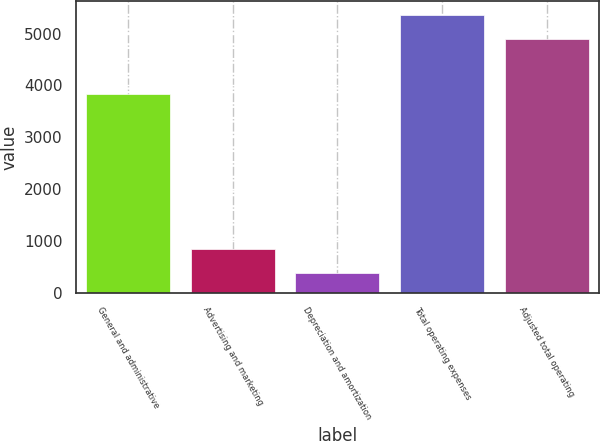Convert chart. <chart><loc_0><loc_0><loc_500><loc_500><bar_chart><fcel>General and administrative<fcel>Advertising and marketing<fcel>Depreciation and amortization<fcel>Total operating expenses<fcel>Adjusted total operating<nl><fcel>3827<fcel>837.2<fcel>373<fcel>5362.2<fcel>4898<nl></chart> 